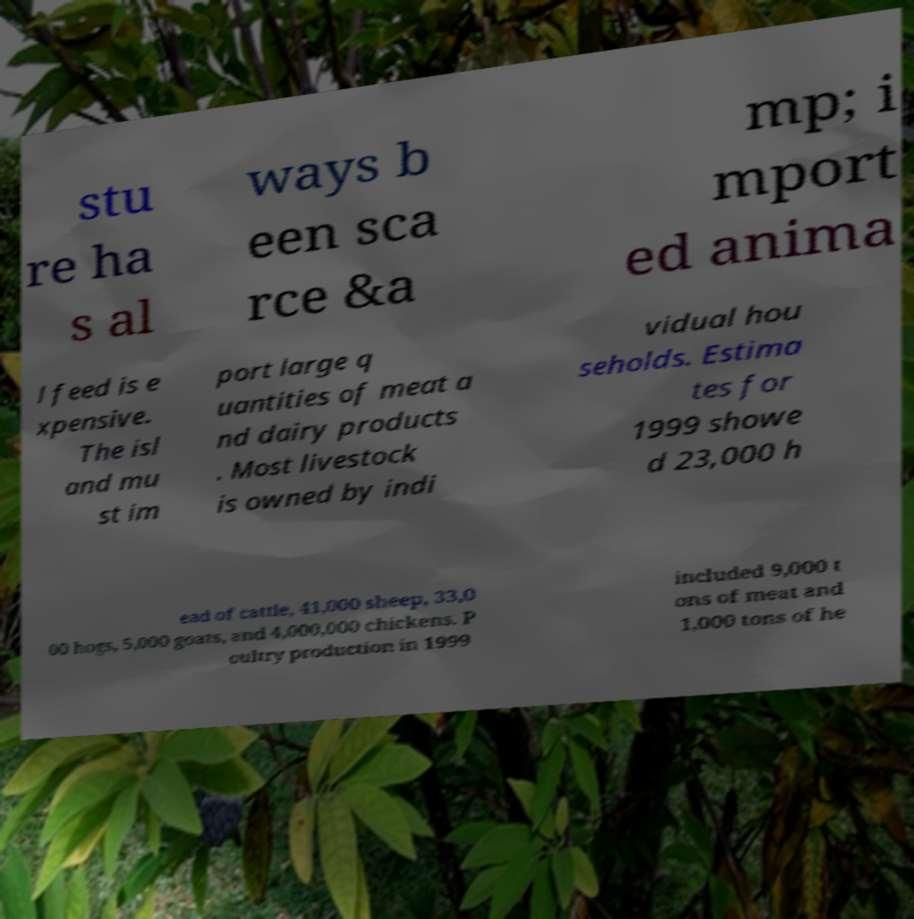Could you extract and type out the text from this image? stu re ha s al ways b een sca rce &a mp; i mport ed anima l feed is e xpensive. The isl and mu st im port large q uantities of meat a nd dairy products . Most livestock is owned by indi vidual hou seholds. Estima tes for 1999 showe d 23,000 h ead of cattle, 41,000 sheep, 33,0 00 hogs, 5,000 goats, and 4,000,000 chickens. P oultry production in 1999 included 9,000 t ons of meat and 1,000 tons of he 